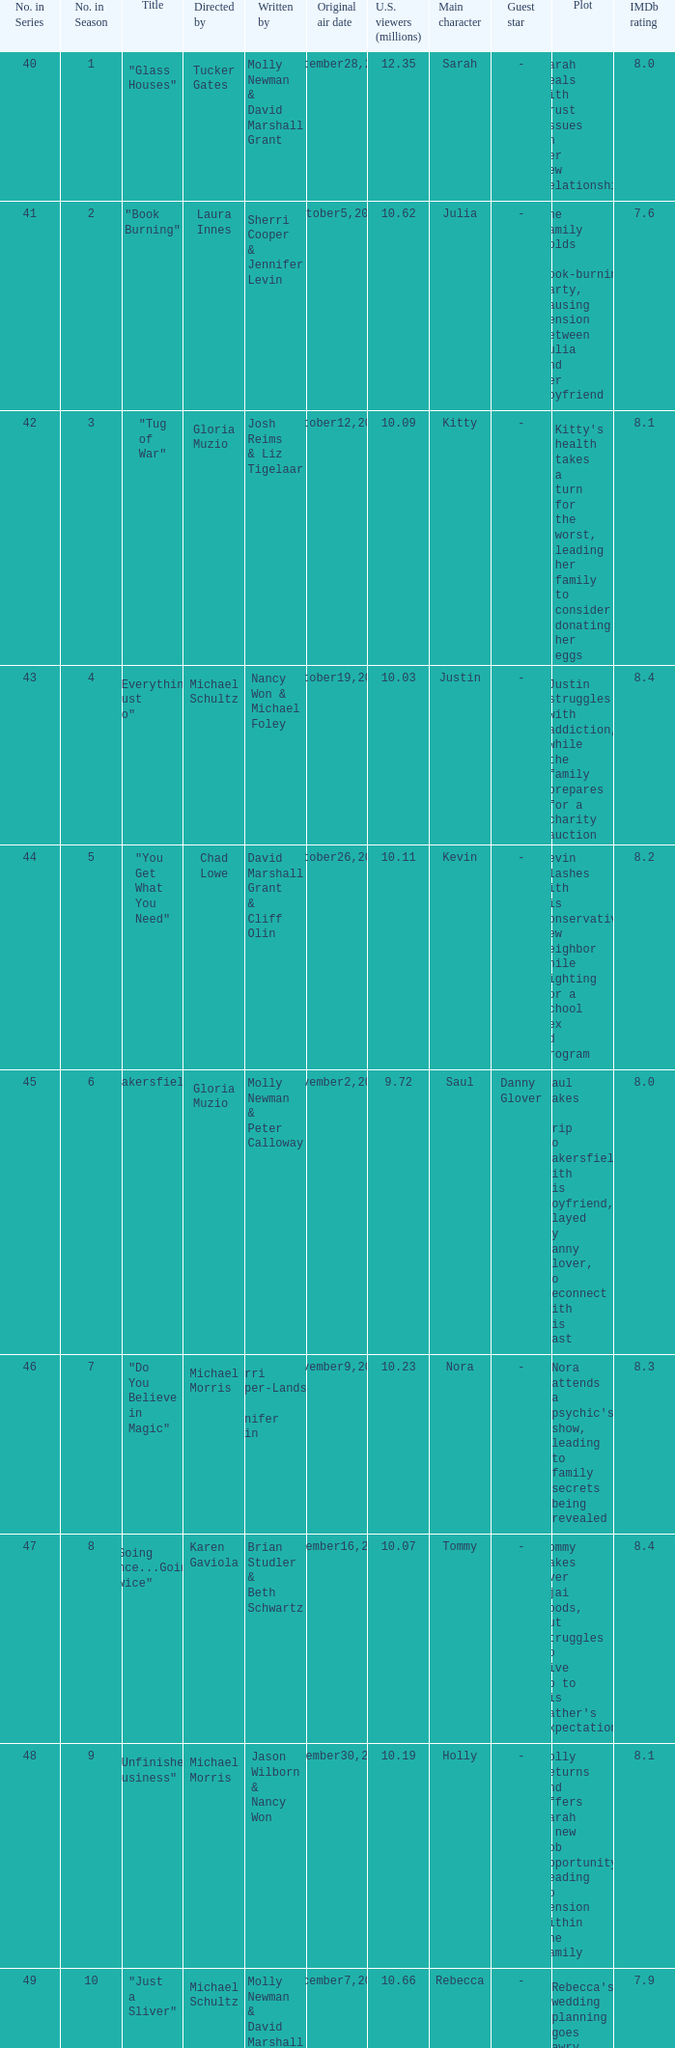What's the name of the episode seen by 9.63 millions of people in the US, whose director is Laura Innes? "S3X". 